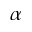<formula> <loc_0><loc_0><loc_500><loc_500>\alpha</formula> 